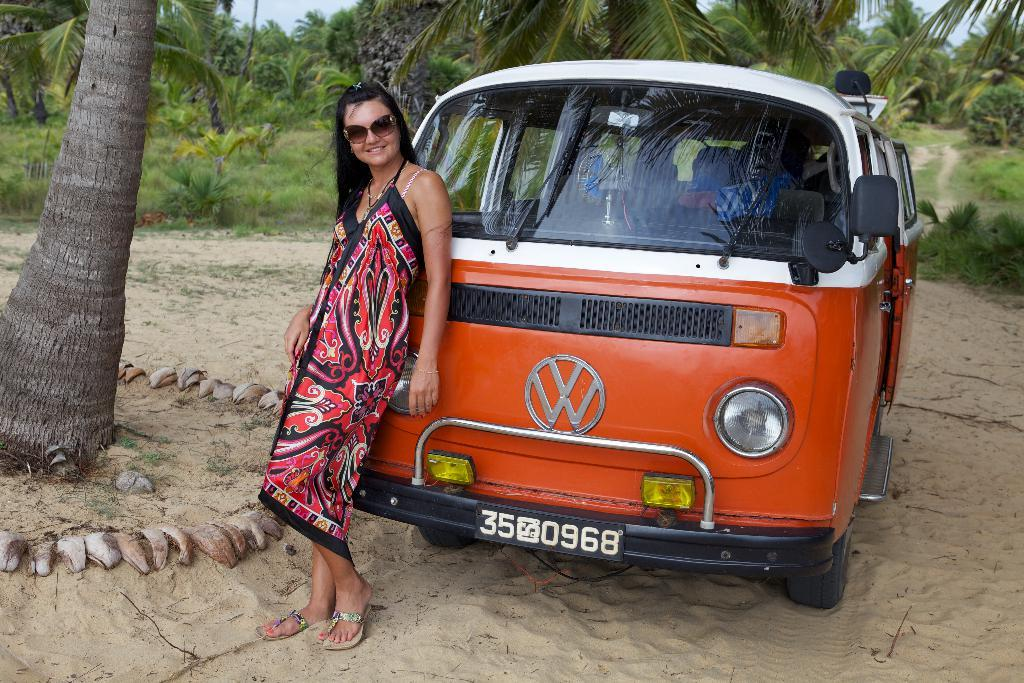Who is present in the image? There is a woman in the image. What is the woman doing in the image? The woman is standing and smiling. What else can be seen in the image besides the woman? There is a vehicle and trees in the background of the image. What is visible in the background of the image? The sky is visible in the background of the image. What type of flag is the coach using to direct the farmer in the image? There is no flag, coach, or farmer present in the image. 